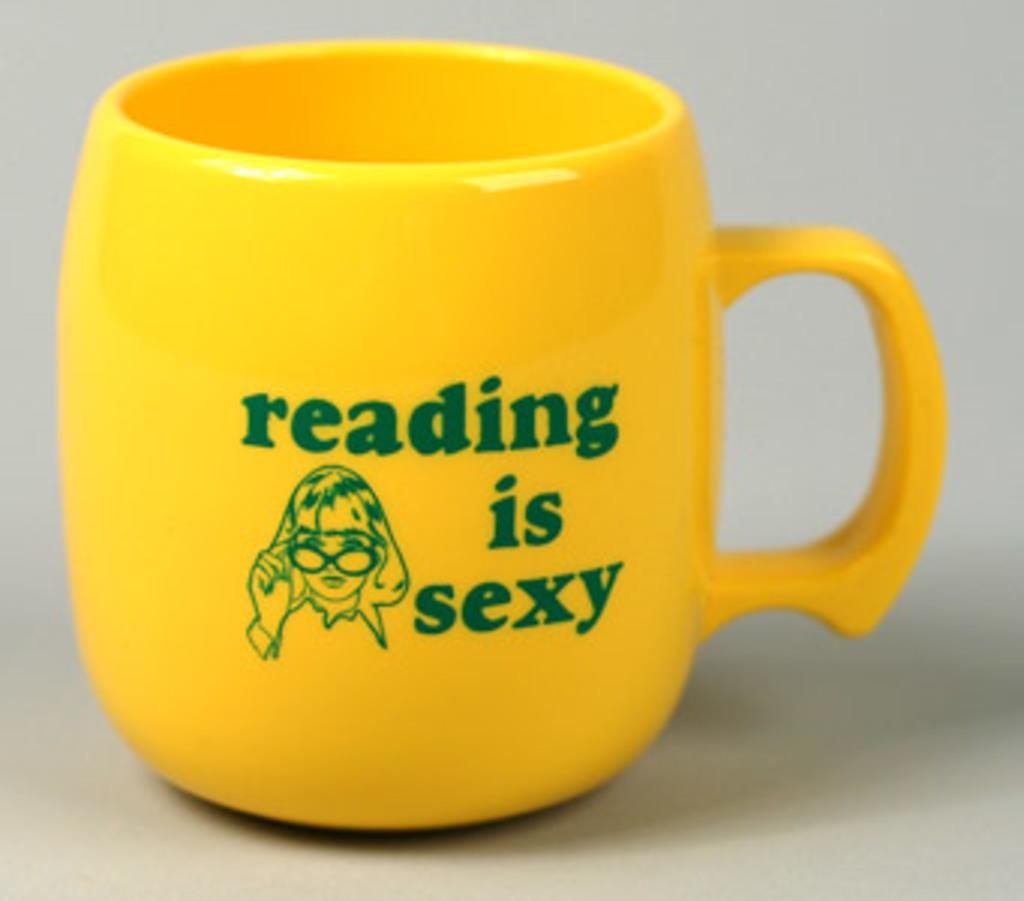<image>
Describe the image concisely. a coffee mug that says "reading is sexy" 